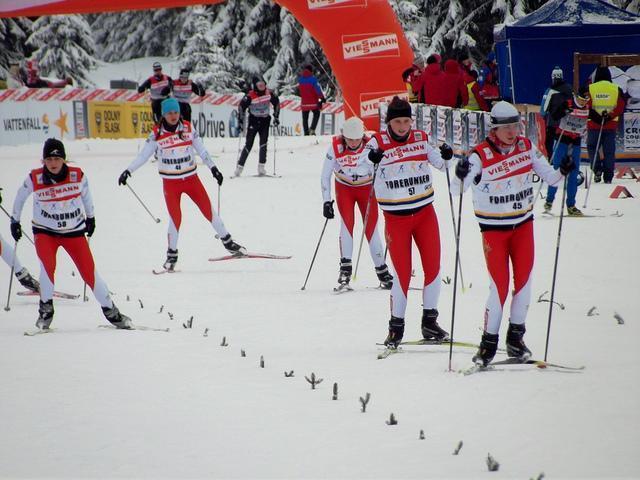How many people are in the picture?
Give a very brief answer. 8. 